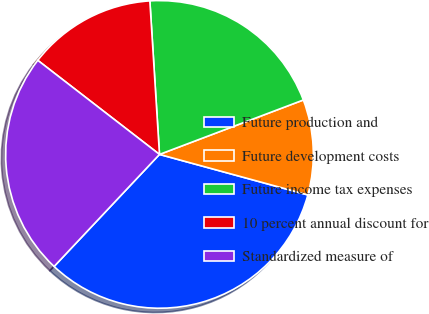Convert chart to OTSL. <chart><loc_0><loc_0><loc_500><loc_500><pie_chart><fcel>Future production and<fcel>Future development costs<fcel>Future income tax expenses<fcel>10 percent annual discount for<fcel>Standardized measure of<nl><fcel>32.77%<fcel>10.0%<fcel>20.24%<fcel>13.53%<fcel>23.46%<nl></chart> 